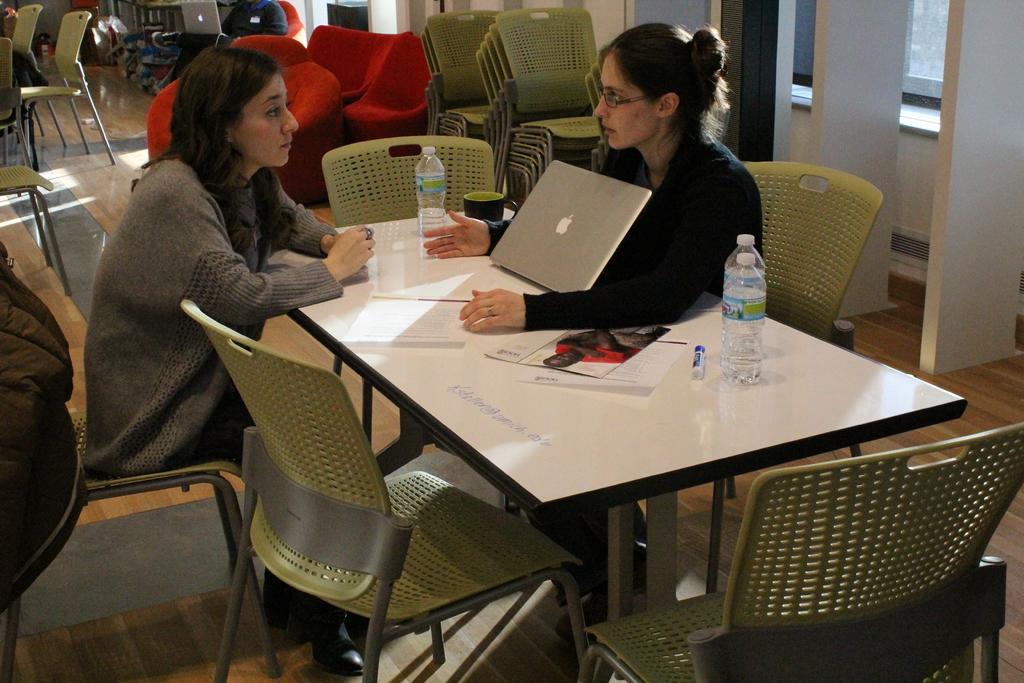In one or two sentences, can you explain what this image depicts? In this picture we can see two persons sitting on chairs in front of a table, there are some chairs here, we can see a laptop, two water bottles and papers on the table, we can see one more person in the background. 